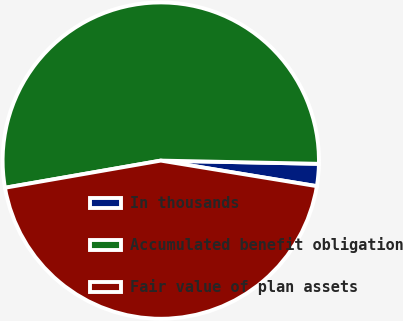Convert chart to OTSL. <chart><loc_0><loc_0><loc_500><loc_500><pie_chart><fcel>In thousands<fcel>Accumulated benefit obligation<fcel>Fair value of plan assets<nl><fcel>2.26%<fcel>53.07%<fcel>44.67%<nl></chart> 